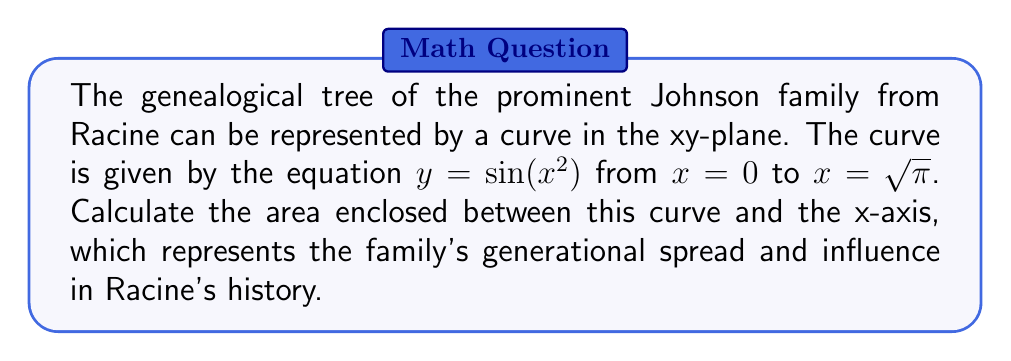Could you help me with this problem? To find the area enclosed by the curve $y = \sin(x^2)$ and the x-axis from $x = 0$ to $x = \sqrt{\pi}$, we need to use definite integration. The steps are as follows:

1) The area is given by the absolute value of the integral:

   $$A = \left|\int_{0}^{\sqrt{\pi}} \sin(x^2) dx\right|$$

2) This integral doesn't have an elementary antiderivative, so we need to use a substitution method:

   Let $u = x^2$, then $du = 2x dx$ or $dx = \frac{1}{2\sqrt{u}} du$

3) When $x = 0$, $u = 0$
   When $x = \sqrt{\pi}$, $u = \pi$

4) Substituting:

   $$A = \left|\int_{0}^{\pi} \sin(u) \cdot \frac{1}{2\sqrt{u}} du\right|$$

5) This is a standard form integral that equals $\frac{\sqrt{\pi}}{2}$

Therefore, the area enclosed by the curve representing the Johnson family's genealogical tree is $\frac{\sqrt{\pi}}{2}$ square units.
Answer: $\frac{\sqrt{\pi}}{2}$ square units 